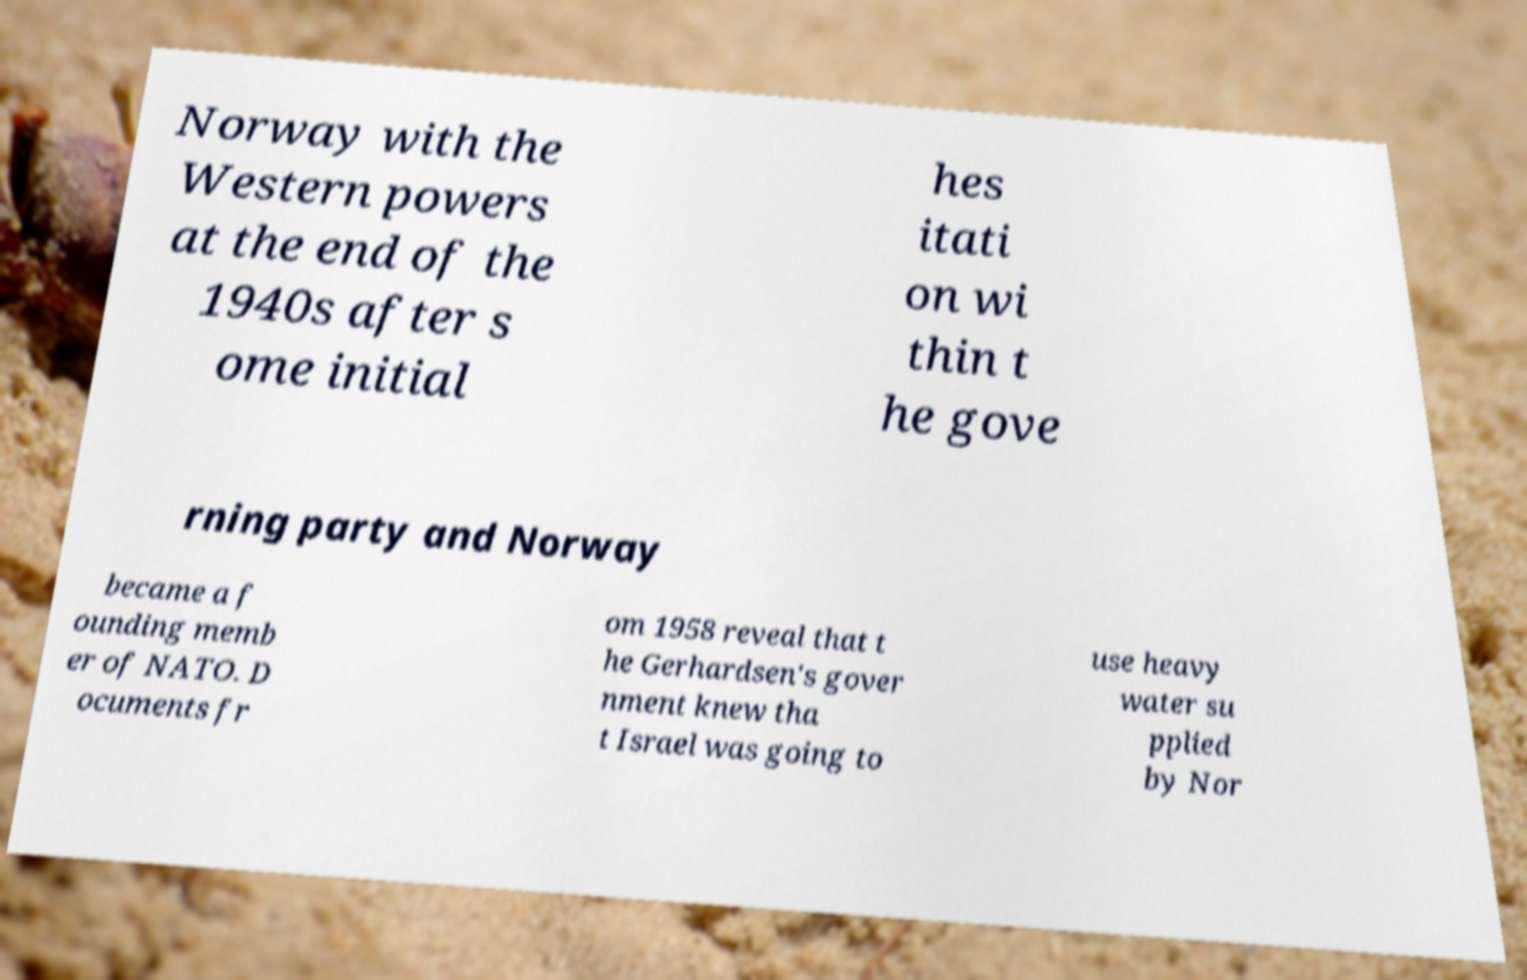Can you accurately transcribe the text from the provided image for me? Norway with the Western powers at the end of the 1940s after s ome initial hes itati on wi thin t he gove rning party and Norway became a f ounding memb er of NATO. D ocuments fr om 1958 reveal that t he Gerhardsen's gover nment knew tha t Israel was going to use heavy water su pplied by Nor 